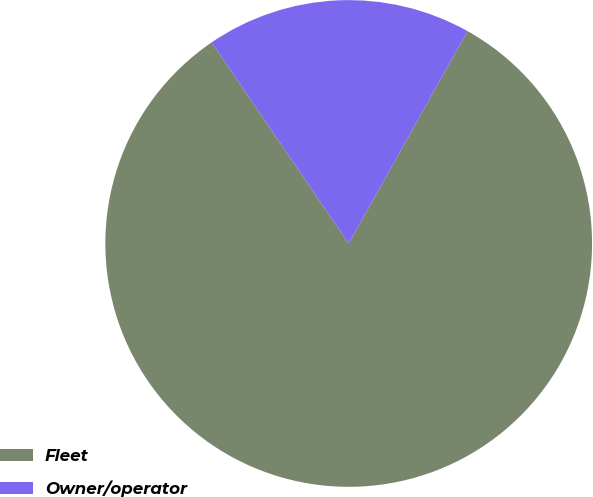Convert chart to OTSL. <chart><loc_0><loc_0><loc_500><loc_500><pie_chart><fcel>Fleet<fcel>Owner/operator<nl><fcel>82.35%<fcel>17.65%<nl></chart> 